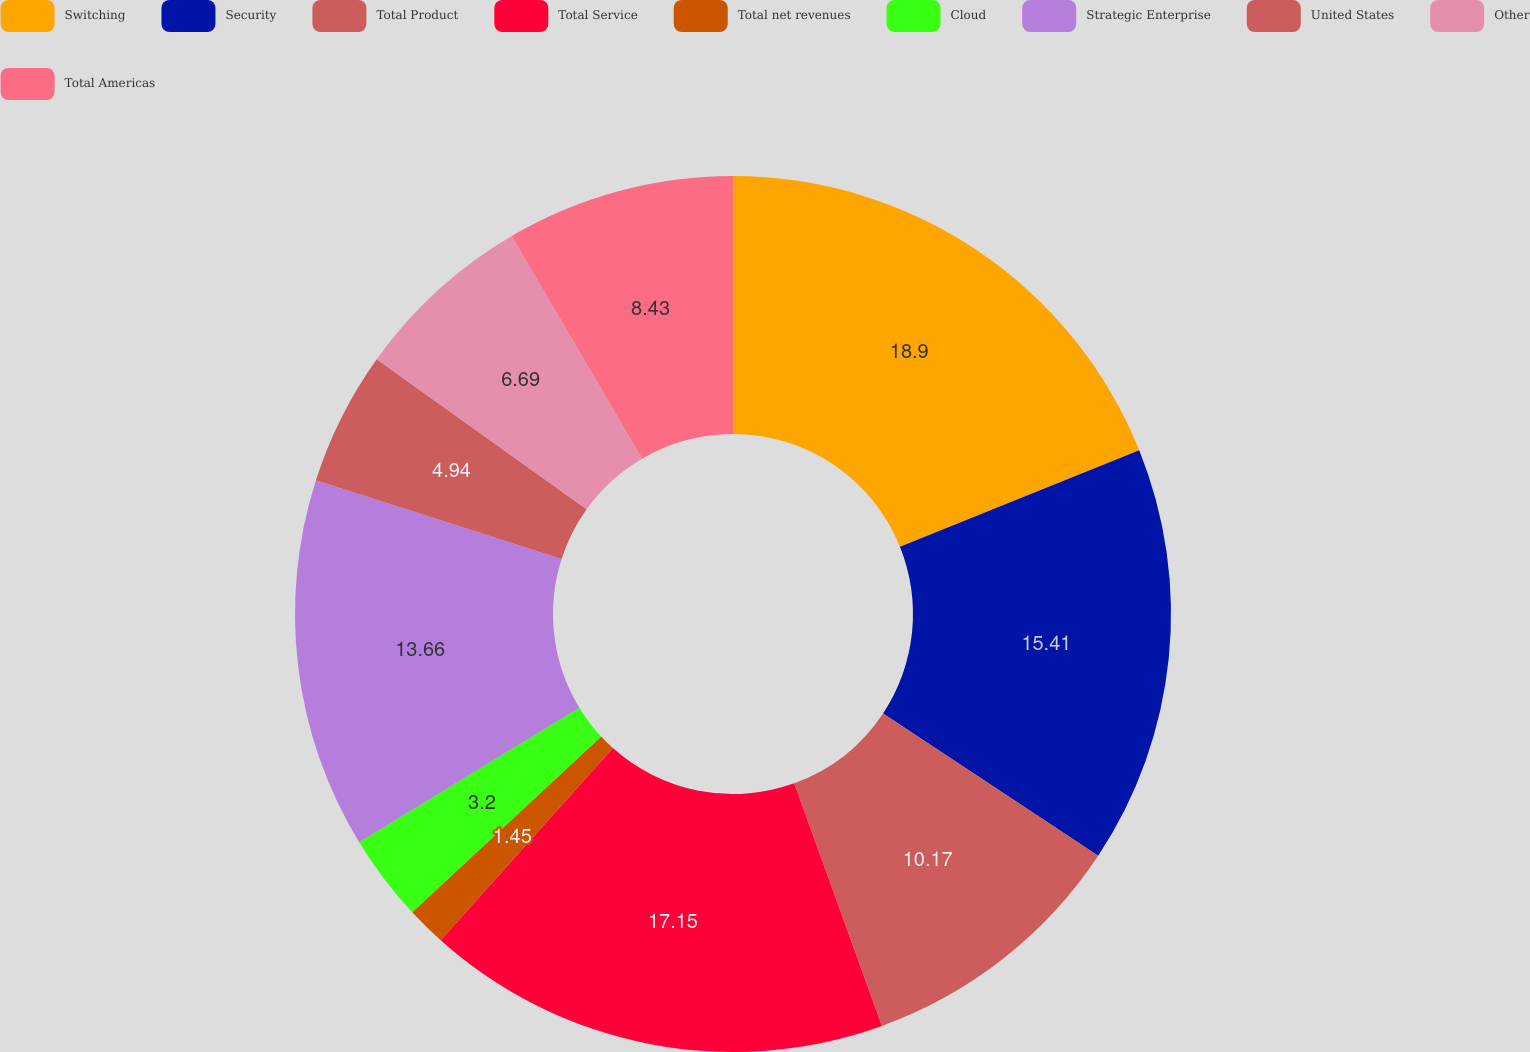<chart> <loc_0><loc_0><loc_500><loc_500><pie_chart><fcel>Switching<fcel>Security<fcel>Total Product<fcel>Total Service<fcel>Total net revenues<fcel>Cloud<fcel>Strategic Enterprise<fcel>United States<fcel>Other<fcel>Total Americas<nl><fcel>18.9%<fcel>15.41%<fcel>10.17%<fcel>17.15%<fcel>1.45%<fcel>3.2%<fcel>13.66%<fcel>4.94%<fcel>6.69%<fcel>8.43%<nl></chart> 